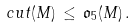Convert formula to latex. <formula><loc_0><loc_0><loc_500><loc_500>c u t ( M ) \, \leq \, { \mathfrak o } _ { 5 } ( M ) \, .</formula> 